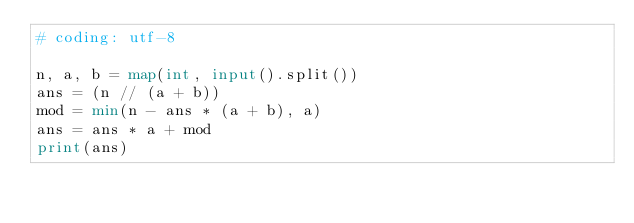<code> <loc_0><loc_0><loc_500><loc_500><_Python_># coding: utf-8

n, a, b = map(int, input().split())
ans = (n // (a + b))
mod = min(n - ans * (a + b), a)
ans = ans * a + mod
print(ans)</code> 